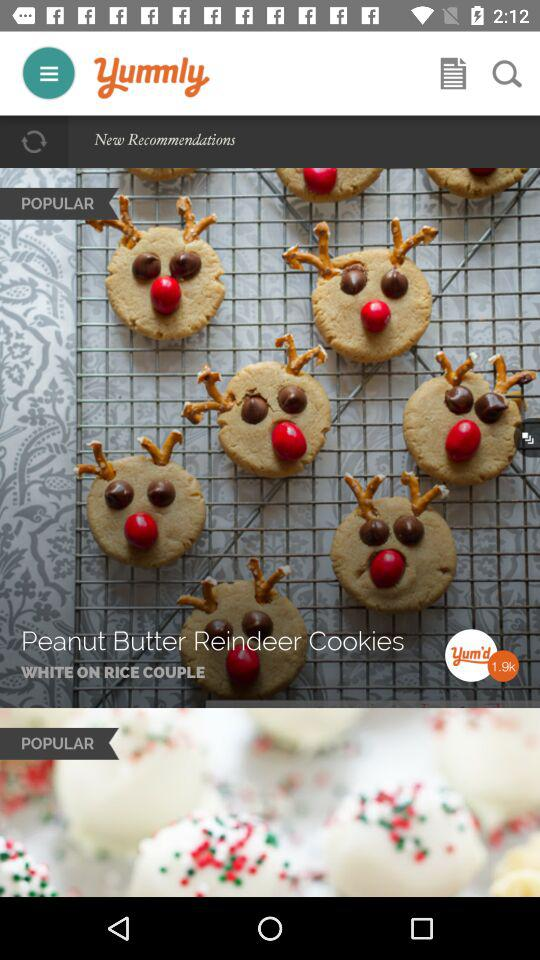What is the name of the application? The name of the application is "Yummly". 